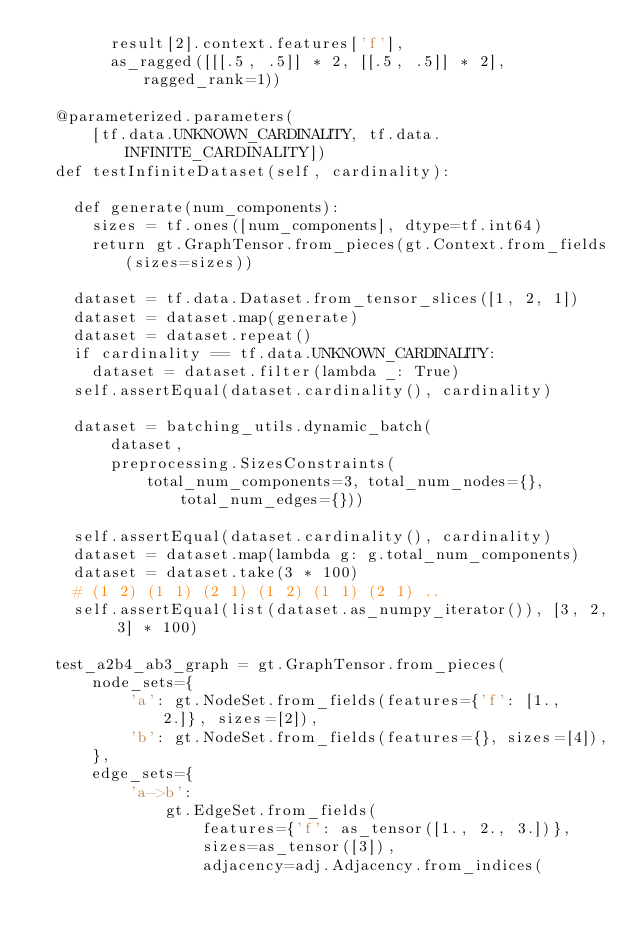<code> <loc_0><loc_0><loc_500><loc_500><_Python_>        result[2].context.features['f'],
        as_ragged([[[.5, .5]] * 2, [[.5, .5]] * 2], ragged_rank=1))

  @parameterized.parameters(
      [tf.data.UNKNOWN_CARDINALITY, tf.data.INFINITE_CARDINALITY])
  def testInfiniteDataset(self, cardinality):

    def generate(num_components):
      sizes = tf.ones([num_components], dtype=tf.int64)
      return gt.GraphTensor.from_pieces(gt.Context.from_fields(sizes=sizes))

    dataset = tf.data.Dataset.from_tensor_slices([1, 2, 1])
    dataset = dataset.map(generate)
    dataset = dataset.repeat()
    if cardinality == tf.data.UNKNOWN_CARDINALITY:
      dataset = dataset.filter(lambda _: True)
    self.assertEqual(dataset.cardinality(), cardinality)

    dataset = batching_utils.dynamic_batch(
        dataset,
        preprocessing.SizesConstraints(
            total_num_components=3, total_num_nodes={}, total_num_edges={}))

    self.assertEqual(dataset.cardinality(), cardinality)
    dataset = dataset.map(lambda g: g.total_num_components)
    dataset = dataset.take(3 * 100)
    # (1 2) (1 1) (2 1) (1 2) (1 1) (2 1) ..
    self.assertEqual(list(dataset.as_numpy_iterator()), [3, 2, 3] * 100)

  test_a2b4_ab3_graph = gt.GraphTensor.from_pieces(
      node_sets={
          'a': gt.NodeSet.from_fields(features={'f': [1., 2.]}, sizes=[2]),
          'b': gt.NodeSet.from_fields(features={}, sizes=[4]),
      },
      edge_sets={
          'a->b':
              gt.EdgeSet.from_fields(
                  features={'f': as_tensor([1., 2., 3.])},
                  sizes=as_tensor([3]),
                  adjacency=adj.Adjacency.from_indices(</code> 